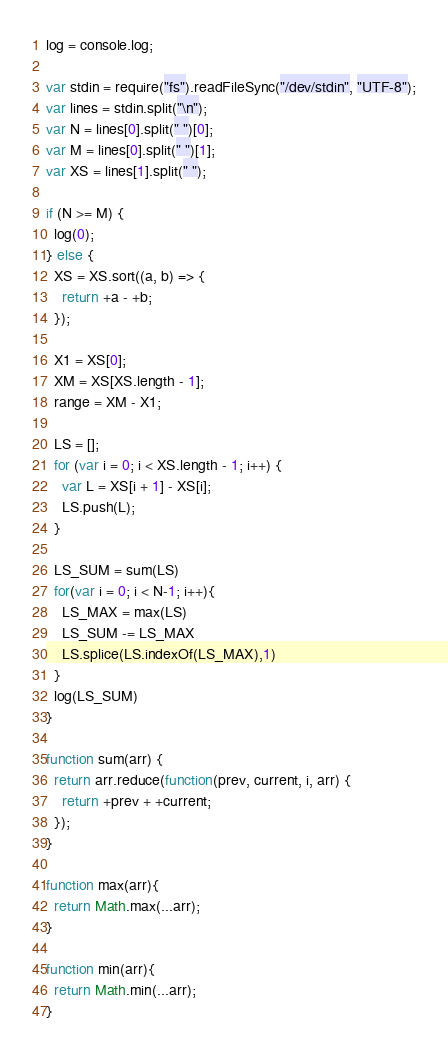<code> <loc_0><loc_0><loc_500><loc_500><_JavaScript_>log = console.log;

var stdin = require("fs").readFileSync("/dev/stdin", "UTF-8");
var lines = stdin.split("\n");
var N = lines[0].split(" ")[0];
var M = lines[0].split(" ")[1];
var XS = lines[1].split(" ");

if (N >= M) {
  log(0);
} else {
  XS = XS.sort((a, b) => {
    return +a - +b;
  });

  X1 = XS[0];
  XM = XS[XS.length - 1];
  range = XM - X1;

  LS = [];
  for (var i = 0; i < XS.length - 1; i++) {
    var L = XS[i + 1] - XS[i];
    LS.push(L);
  }

  LS_SUM = sum(LS)
  for(var i = 0; i < N-1; i++){
    LS_MAX = max(LS)
    LS_SUM -= LS_MAX
    LS.splice(LS.indexOf(LS_MAX),1)
  }
  log(LS_SUM)
}

function sum(arr) {
  return arr.reduce(function(prev, current, i, arr) {
    return +prev + +current;
  });
}

function max(arr){
  return Math.max(...arr);
}

function min(arr){
  return Math.min(...arr);
}</code> 